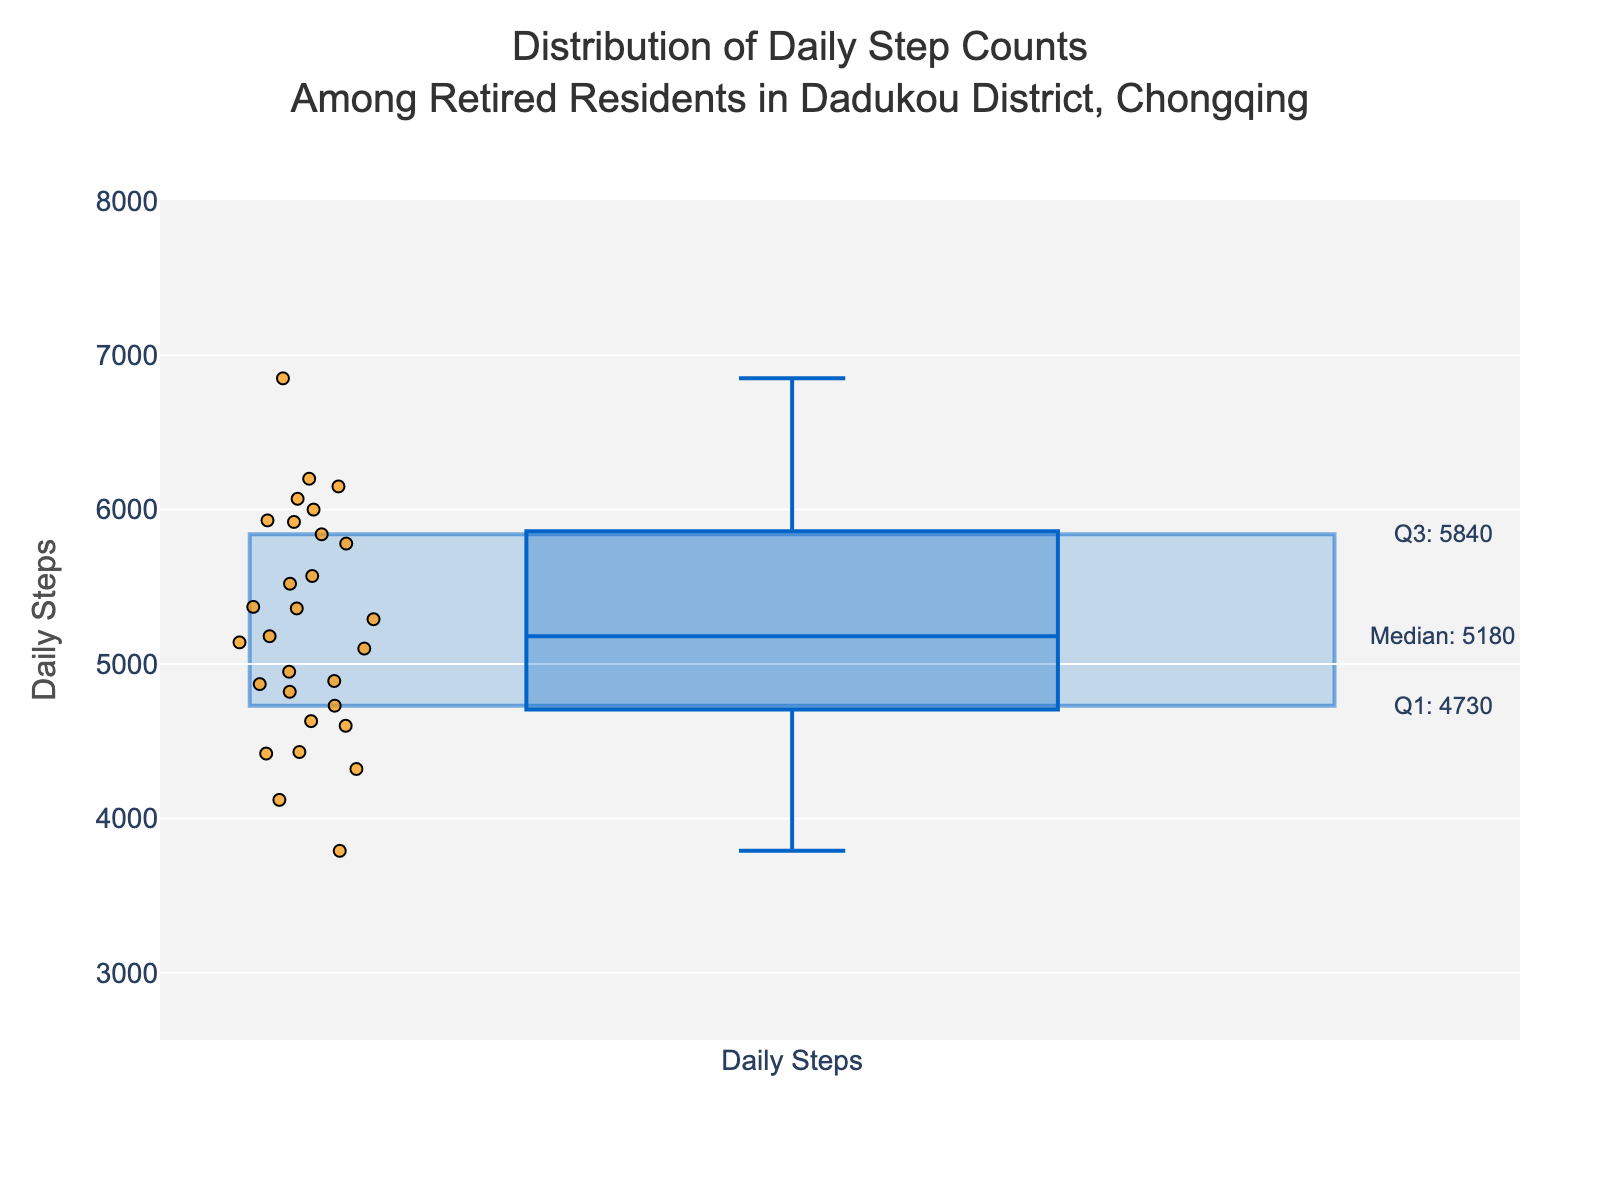How many data points are shown in the plot? Count the number of individual points displayed in the box plot. Each point represents a daily step count of a retired resident.
Answer: 30 What is the median daily step count? The median value is visually indicated by the line inside the box. Look for the annotated "Median" value on the plot.
Answer: 5140 What are the values of the first and third quartiles (Q1 and Q3)? The first and third quartiles are visually indicated by the lower and upper edges of the box, respectively. The plot annotations also provide these values.
Answer: Q1: 4730, Q3: 5920 What is the interquartile range (IQR) for the daily step counts? The interquartile range is the difference between the third quartile (Q3) and the first quartile (Q1). Subtract Q1 from Q3.
Answer: 1190 Are there any outliers in the data? Outliers are typically points that fall below Q1 - 1.5*IQR or above Q3 + 1.5*IQR. Check for any points beyond the whiskers in the plot.
Answer: No What is the lower bound and upper bound of the data? The lower bound is calculated as Q1 - 1.5*IQR and the upper bound is Q3 + 1.5*IQR. These bounds are displayed at the ends of the whiskers.
Answer: Lower bound: 2945, Upper bound: 8705 What is the range of daily step counts covered by the interquartile range? The interquartile range covers the middle 50% of data points. It is between Q1 and Q3, which are also visually represented by the box edges.
Answer: 4730 to 5920 What percentage of the data lies within the interquartile range? By definition, the interquartile range covers the middle 50% of the data.
Answer: 50% What is the highest daily step count recorded among the residents? Identify the maximum point displayed within the range of the box plot.
Answer: 6850 Which resident has the highest daily step count and what is it? Find the individual data point that represents the highest value. According to the data provided, match this with the corresponding resident.
Answer: Li Yang, 6850 